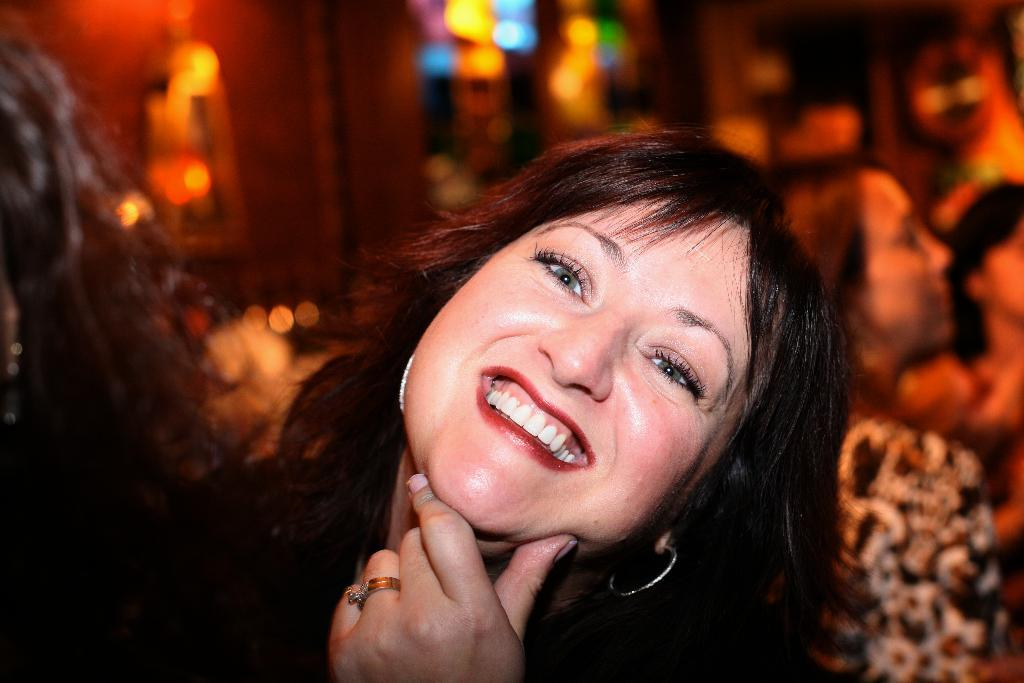Who is the main subject in the image? There is a woman in the front of the image. What can be seen in the background of the image? There is a wall and lights in the background of the image. How is the background of the image depicted? The background is slightly blurred. What type of paste is being used by the woman in the image? There is no paste present in the image, and the woman is not using any paste. 